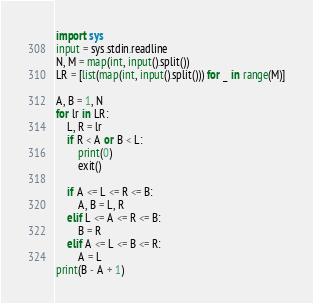Convert code to text. <code><loc_0><loc_0><loc_500><loc_500><_Python_>import sys
input = sys.stdin.readline
N, M = map(int, input().split())
LR = [list(map(int, input().split())) for _ in range(M)]

A, B = 1, N
for lr in LR:
    L, R = lr
    if R < A or B < L:
        print(0)
        exit()

    if A <= L <= R <= B:
        A, B = L, R
    elif L <= A <= R <= B:
        B = R
    elif A <= L <= B <= R:
        A = L
print(B - A + 1)
</code> 